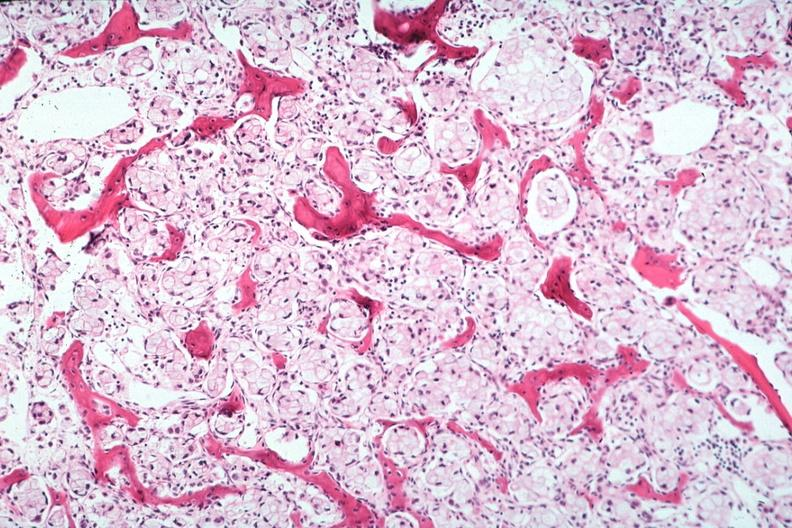s this image shows wrights typical present?
Answer the question using a single word or phrase. No 